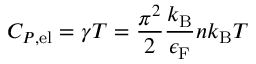<formula> <loc_0><loc_0><loc_500><loc_500>C _ { P , { e l } } = \gamma T = { \frac { \pi ^ { 2 } } { 2 } } { \frac { k _ { B } } { \epsilon _ { F } } } n k _ { B } T</formula> 